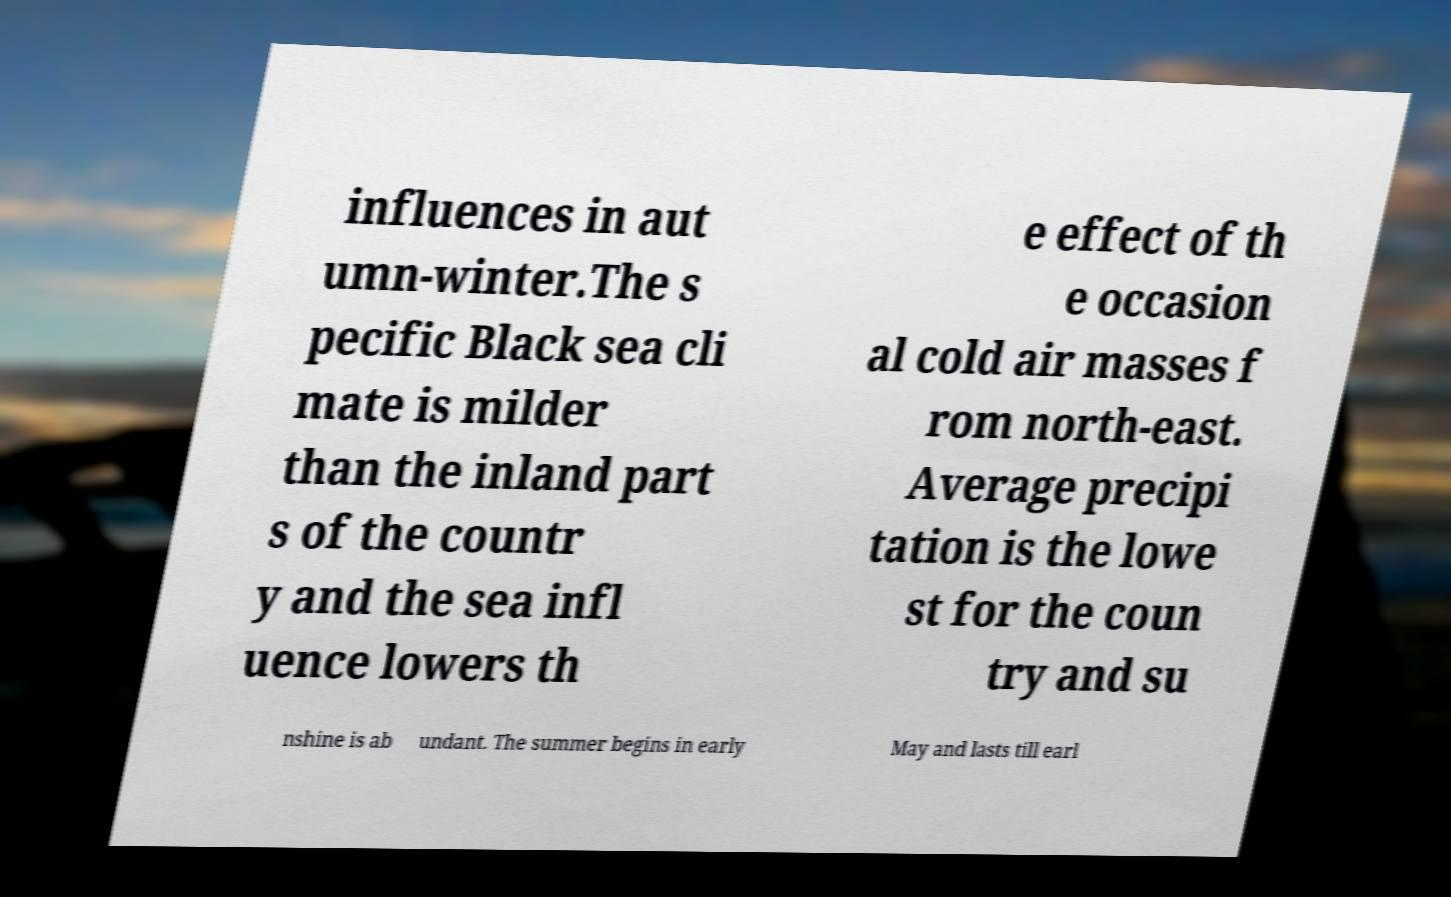For documentation purposes, I need the text within this image transcribed. Could you provide that? influences in aut umn-winter.The s pecific Black sea cli mate is milder than the inland part s of the countr y and the sea infl uence lowers th e effect of th e occasion al cold air masses f rom north-east. Average precipi tation is the lowe st for the coun try and su nshine is ab undant. The summer begins in early May and lasts till earl 